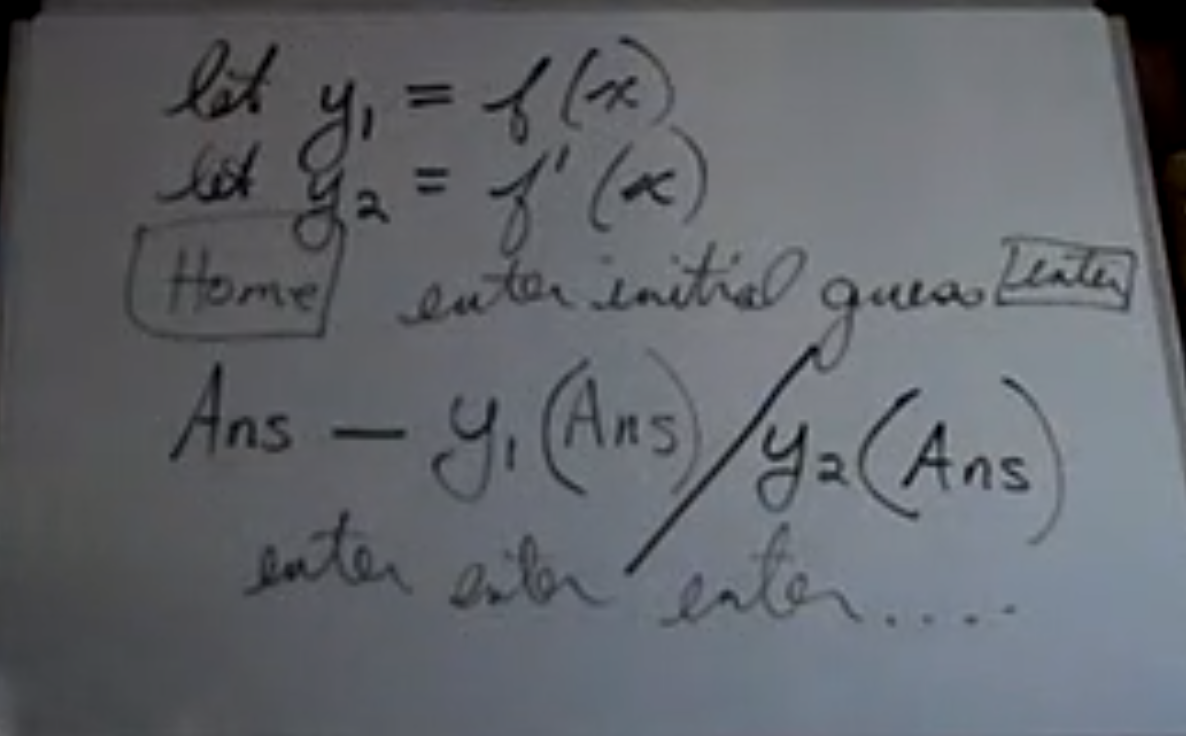What does this say?
 The image shows handwritten mathematical equations and notes:

Let y1 = f(x)
Let y2 = f'(x) = dy/dx
Home
Ans → y1(Ans) y2(Ans)
enter enter enter

It appears to be explaining how to enter an equation f(x) and have it output both the original function value y1 and its derivative y2 at the input value x (labeled "Ans" here). The repeated "enter" at the bottom likely refers to pressing the Enter key to execute the steps. 